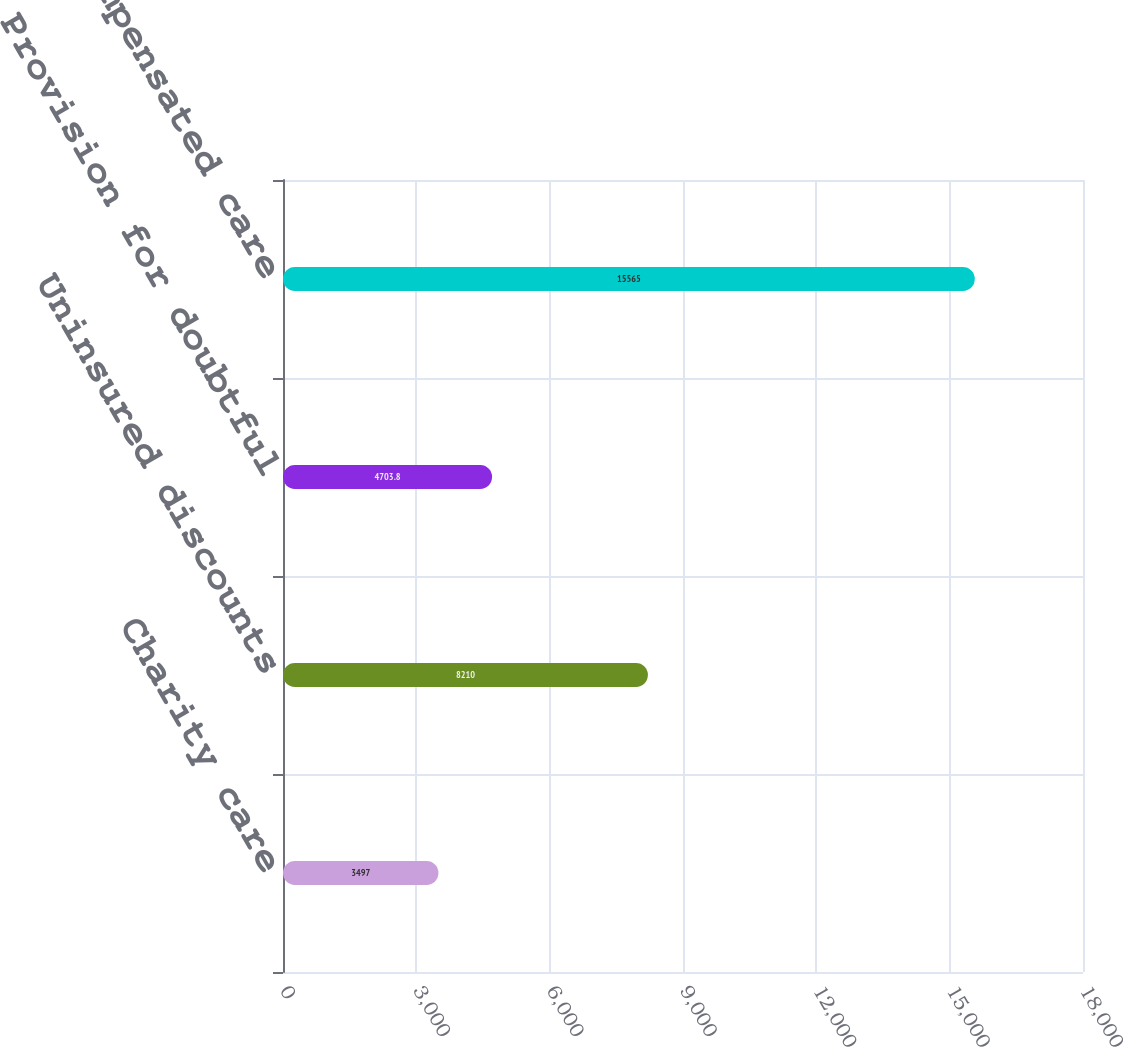Convert chart. <chart><loc_0><loc_0><loc_500><loc_500><bar_chart><fcel>Charity care<fcel>Uninsured discounts<fcel>Provision for doubtful<fcel>Total uncompensated care<nl><fcel>3497<fcel>8210<fcel>4703.8<fcel>15565<nl></chart> 